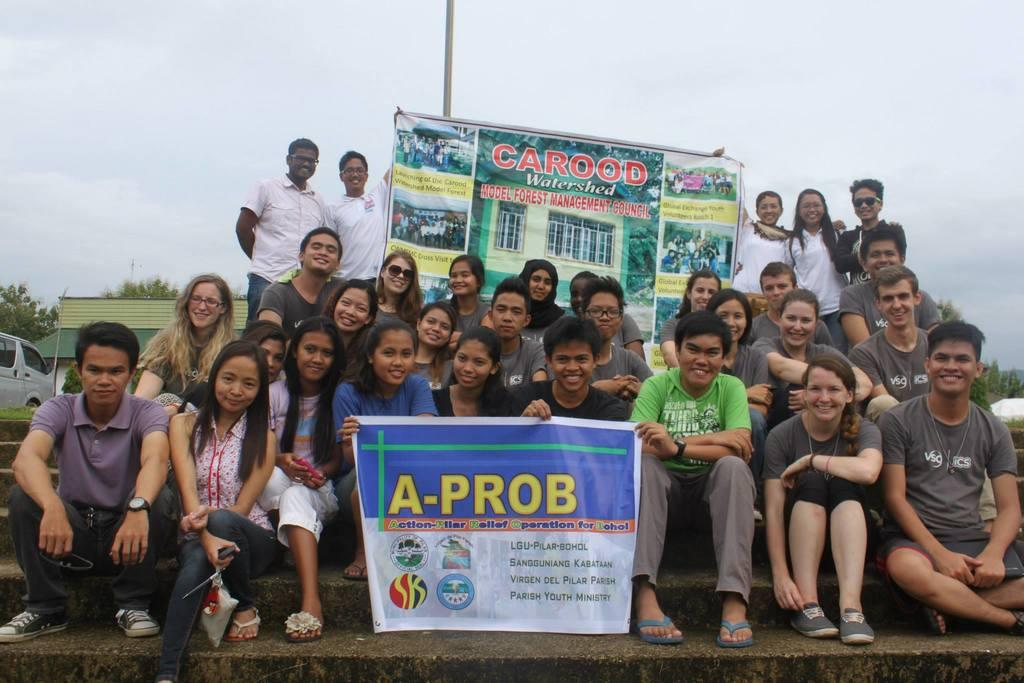How many people are in the image? There is a group of people in the image, but the exact number cannot be determined from the provided facts. What can be seen hanging in the image? There are banners in the image. What type of vehicle is present in the image? There is a car in the image. What type of vegetation is visible in the image? There are trees in the image. What type of structure is visible in the image? There is a house in the image. What is visible at the top of the image? The sky is visible at the top of the image. What type of straw is being used to cover the thing in the image? There is no straw or thing present in the image. Is there a veil covering any part of the house in the image? No, there is no veil covering any part of the house in the image. 